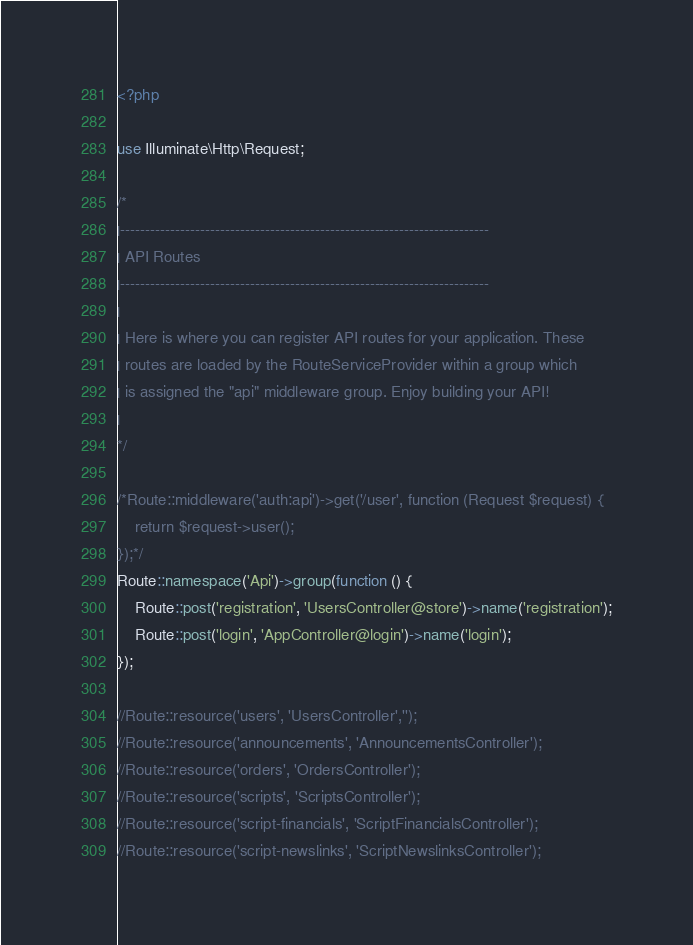Convert code to text. <code><loc_0><loc_0><loc_500><loc_500><_PHP_><?php

use Illuminate\Http\Request;

/*
|--------------------------------------------------------------------------
| API Routes
|--------------------------------------------------------------------------
|
| Here is where you can register API routes for your application. These
| routes are loaded by the RouteServiceProvider within a group which
| is assigned the "api" middleware group. Enjoy building your API!
|
*/

/*Route::middleware('auth:api')->get('/user', function (Request $request) {
    return $request->user();
});*/
Route::namespace('Api')->group(function () {
    Route::post('registration', 'UsersController@store')->name('registration');
    Route::post('login', 'AppController@login')->name('login');
});

//Route::resource('users', 'UsersController','');
//Route::resource('announcements', 'AnnouncementsController');
//Route::resource('orders', 'OrdersController');
//Route::resource('scripts', 'ScriptsController');
//Route::resource('script-financials', 'ScriptFinancialsController');
//Route::resource('script-newslinks', 'ScriptNewslinksController');
</code> 